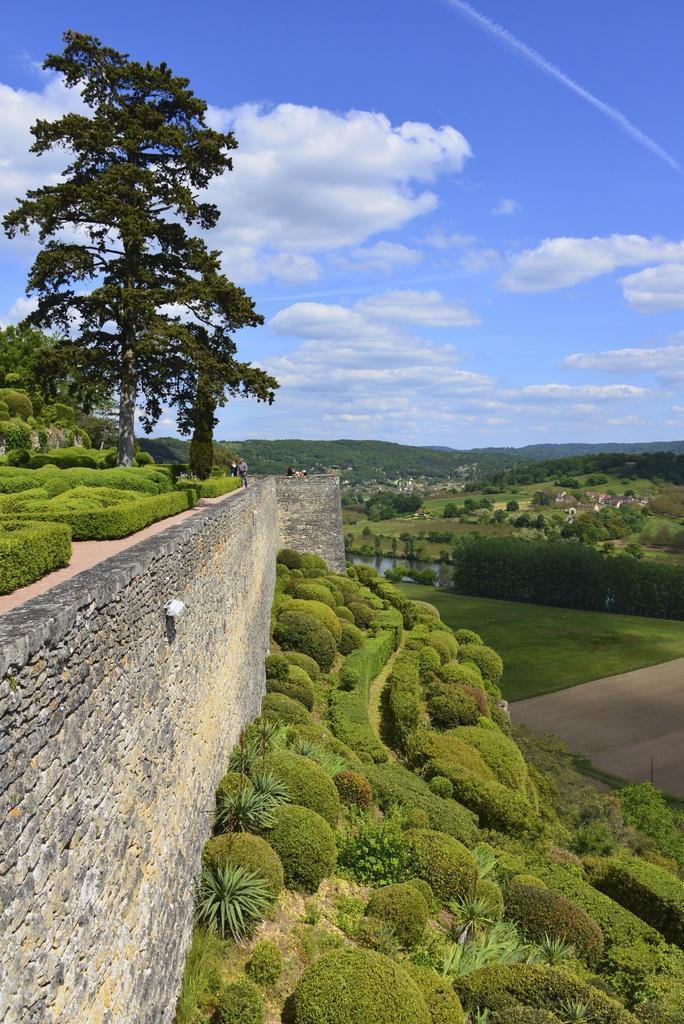Could you give a brief overview of what you see in this image? In this picture I can observe a wall on the left side. There are some plants and trees in this picture. In the background I can observe some clouds in the sky. 